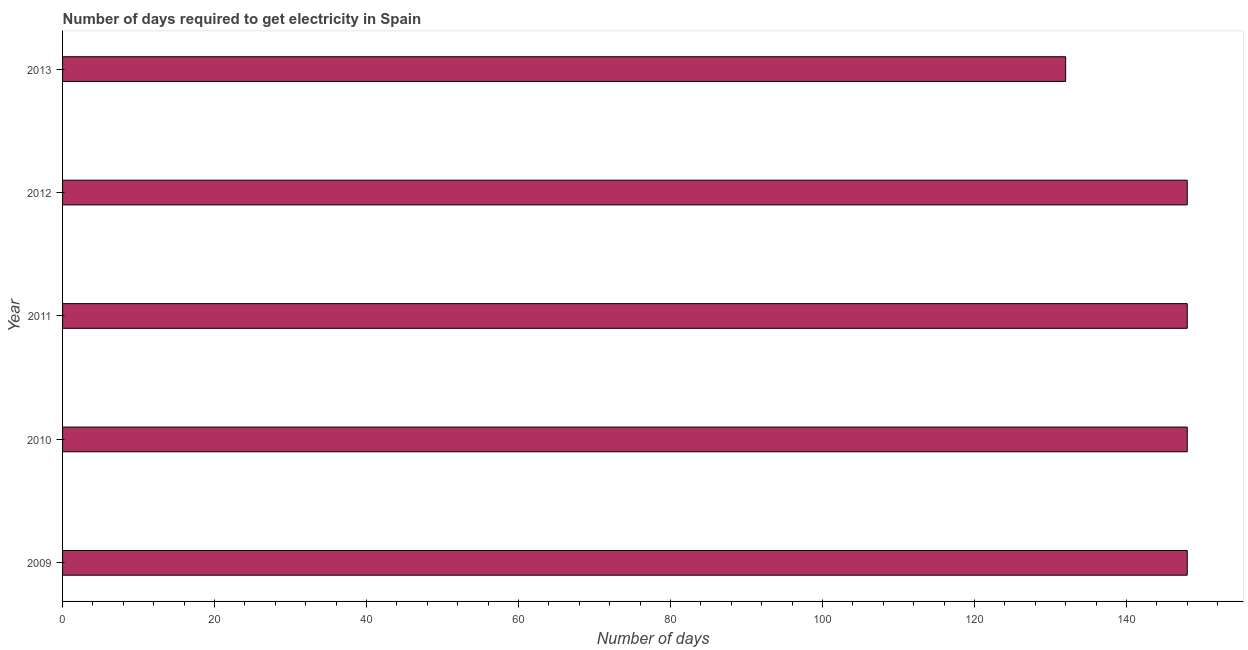What is the title of the graph?
Provide a succinct answer. Number of days required to get electricity in Spain. What is the label or title of the X-axis?
Your response must be concise. Number of days. What is the time to get electricity in 2010?
Your answer should be compact. 148. Across all years, what is the maximum time to get electricity?
Ensure brevity in your answer.  148. Across all years, what is the minimum time to get electricity?
Your response must be concise. 132. In which year was the time to get electricity maximum?
Offer a very short reply. 2009. What is the sum of the time to get electricity?
Offer a terse response. 724. What is the average time to get electricity per year?
Offer a terse response. 144. What is the median time to get electricity?
Your response must be concise. 148. What is the ratio of the time to get electricity in 2009 to that in 2010?
Give a very brief answer. 1. Is the sum of the time to get electricity in 2011 and 2013 greater than the maximum time to get electricity across all years?
Your answer should be very brief. Yes. What is the difference between the highest and the lowest time to get electricity?
Ensure brevity in your answer.  16. Are all the bars in the graph horizontal?
Provide a short and direct response. Yes. Are the values on the major ticks of X-axis written in scientific E-notation?
Your answer should be compact. No. What is the Number of days of 2009?
Offer a terse response. 148. What is the Number of days of 2010?
Provide a succinct answer. 148. What is the Number of days in 2011?
Your response must be concise. 148. What is the Number of days of 2012?
Your answer should be compact. 148. What is the Number of days in 2013?
Your answer should be compact. 132. What is the difference between the Number of days in 2009 and 2011?
Your response must be concise. 0. What is the difference between the Number of days in 2009 and 2012?
Your response must be concise. 0. What is the difference between the Number of days in 2009 and 2013?
Keep it short and to the point. 16. What is the difference between the Number of days in 2011 and 2012?
Offer a very short reply. 0. What is the difference between the Number of days in 2011 and 2013?
Ensure brevity in your answer.  16. What is the difference between the Number of days in 2012 and 2013?
Your answer should be very brief. 16. What is the ratio of the Number of days in 2009 to that in 2010?
Keep it short and to the point. 1. What is the ratio of the Number of days in 2009 to that in 2012?
Offer a terse response. 1. What is the ratio of the Number of days in 2009 to that in 2013?
Your answer should be compact. 1.12. What is the ratio of the Number of days in 2010 to that in 2011?
Your answer should be very brief. 1. What is the ratio of the Number of days in 2010 to that in 2012?
Your answer should be very brief. 1. What is the ratio of the Number of days in 2010 to that in 2013?
Ensure brevity in your answer.  1.12. What is the ratio of the Number of days in 2011 to that in 2012?
Provide a short and direct response. 1. What is the ratio of the Number of days in 2011 to that in 2013?
Provide a short and direct response. 1.12. What is the ratio of the Number of days in 2012 to that in 2013?
Make the answer very short. 1.12. 